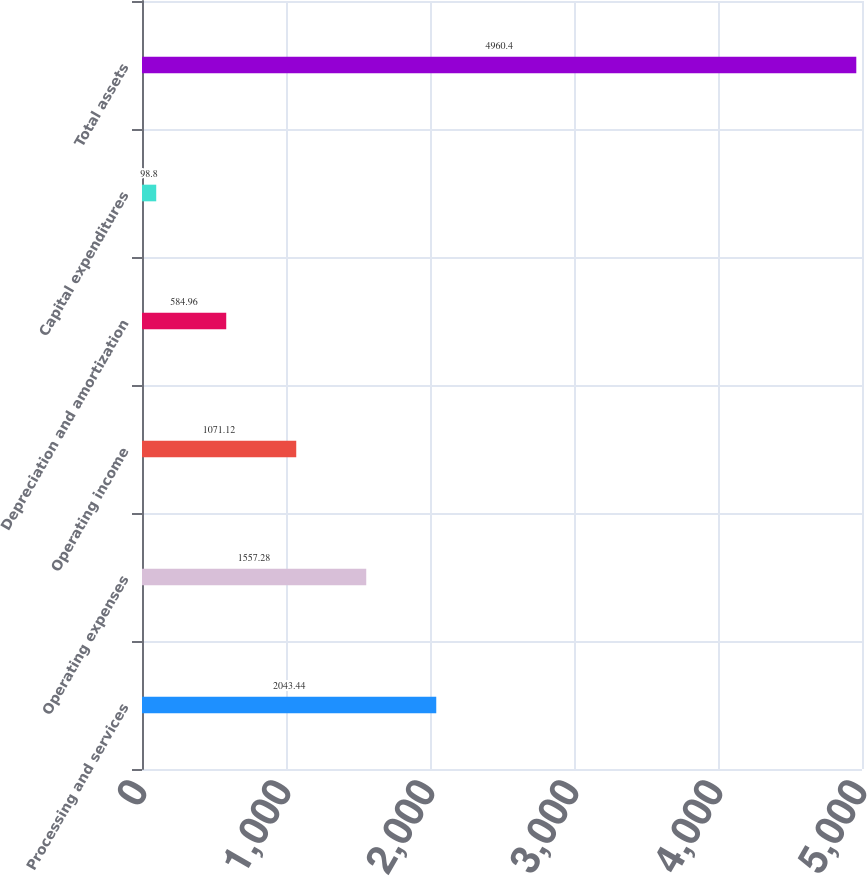Convert chart. <chart><loc_0><loc_0><loc_500><loc_500><bar_chart><fcel>Processing and services<fcel>Operating expenses<fcel>Operating income<fcel>Depreciation and amortization<fcel>Capital expenditures<fcel>Total assets<nl><fcel>2043.44<fcel>1557.28<fcel>1071.12<fcel>584.96<fcel>98.8<fcel>4960.4<nl></chart> 